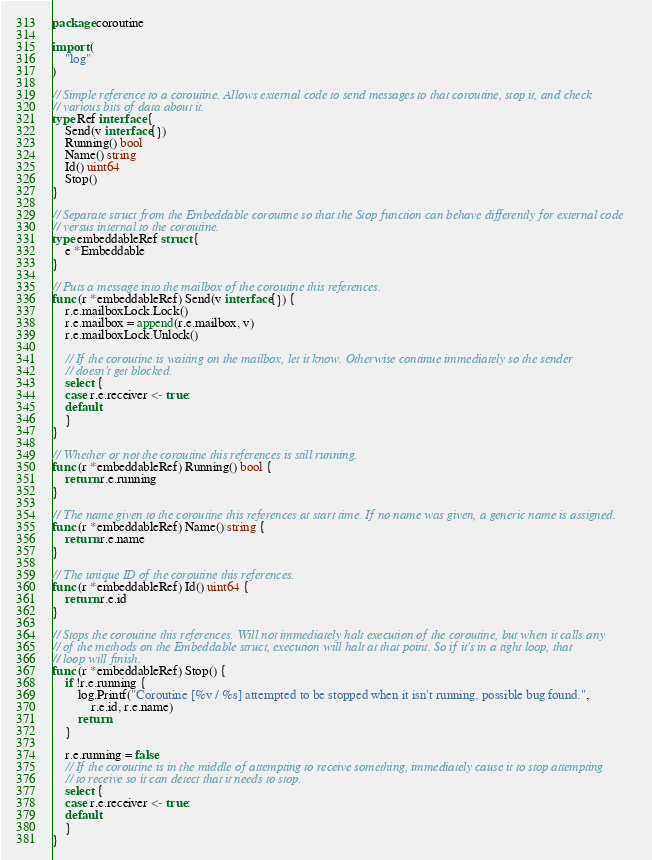Convert code to text. <code><loc_0><loc_0><loc_500><loc_500><_Go_>package coroutine

import (
	"log"
)

// Simple reference to a coroutine. Allows external code to send messages to that coroutine, stop it, and check
// various bits of data about it.
type Ref interface {
	Send(v interface{})
	Running() bool
	Name() string
	Id() uint64
	Stop()
}

// Separate struct from the Embeddable coroutine so that the Stop function can behave differently for external code
// versus internal to the coroutine.
type embeddableRef struct {
	e *Embeddable
}

// Puts a message into the mailbox of the coroutine this references.
func (r *embeddableRef) Send(v interface{}) {
	r.e.mailboxLock.Lock()
	r.e.mailbox = append(r.e.mailbox, v)
	r.e.mailboxLock.Unlock()

	// If the coroutine is waiting on the mailbox, let it know. Otherwise continue immediately so the sender
	// doesn't get blocked.
	select {
	case r.e.receiver <- true:
	default:
	}
}

// Whether or not the coroutine this references is still running.
func (r *embeddableRef) Running() bool {
	return r.e.running
}

// The name given to the coroutine this references at start time. If no name was given, a generic name is assigned.
func (r *embeddableRef) Name() string {
	return r.e.name
}

// The unique ID of the coroutine this references.
func (r *embeddableRef) Id() uint64 {
	return r.e.id
}

// Stops the coroutine this references. Will not immediately halt execution of the coroutine, but when it calls any
// of the methods on the Embeddable struct, execution will halt at that point. So if it's in a tight loop, that
// loop will finish.
func (r *embeddableRef) Stop() {
	if !r.e.running {
		log.Printf("Coroutine [%v / %s] attempted to be stopped when it isn't running, possible bug found.",
			r.e.id, r.e.name)
		return
	}

	r.e.running = false
	// If the coroutine is in the middle of attempting to receive something, immediately cause it to stop attempting
	// to receive so it can detect that it needs to stop.
	select {
	case r.e.receiver <- true:
	default:
	}
}
</code> 